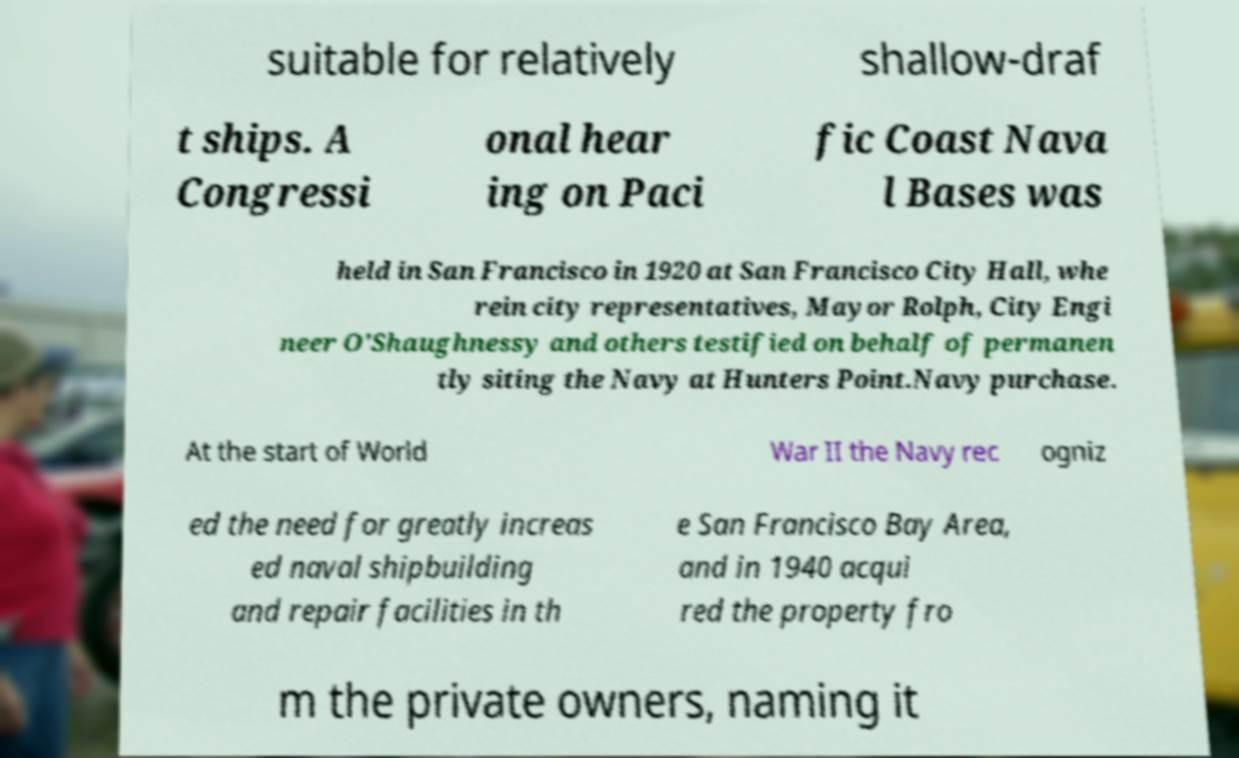Please identify and transcribe the text found in this image. suitable for relatively shallow-draf t ships. A Congressi onal hear ing on Paci fic Coast Nava l Bases was held in San Francisco in 1920 at San Francisco City Hall, whe rein city representatives, Mayor Rolph, City Engi neer O'Shaughnessy and others testified on behalf of permanen tly siting the Navy at Hunters Point.Navy purchase. At the start of World War II the Navy rec ogniz ed the need for greatly increas ed naval shipbuilding and repair facilities in th e San Francisco Bay Area, and in 1940 acqui red the property fro m the private owners, naming it 